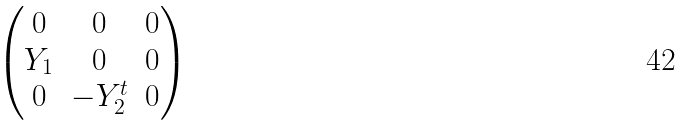<formula> <loc_0><loc_0><loc_500><loc_500>\begin{pmatrix} 0 & 0 & 0 \\ Y _ { 1 } & 0 & 0 \\ 0 & - Y _ { 2 } ^ { t } & 0 \end{pmatrix}</formula> 